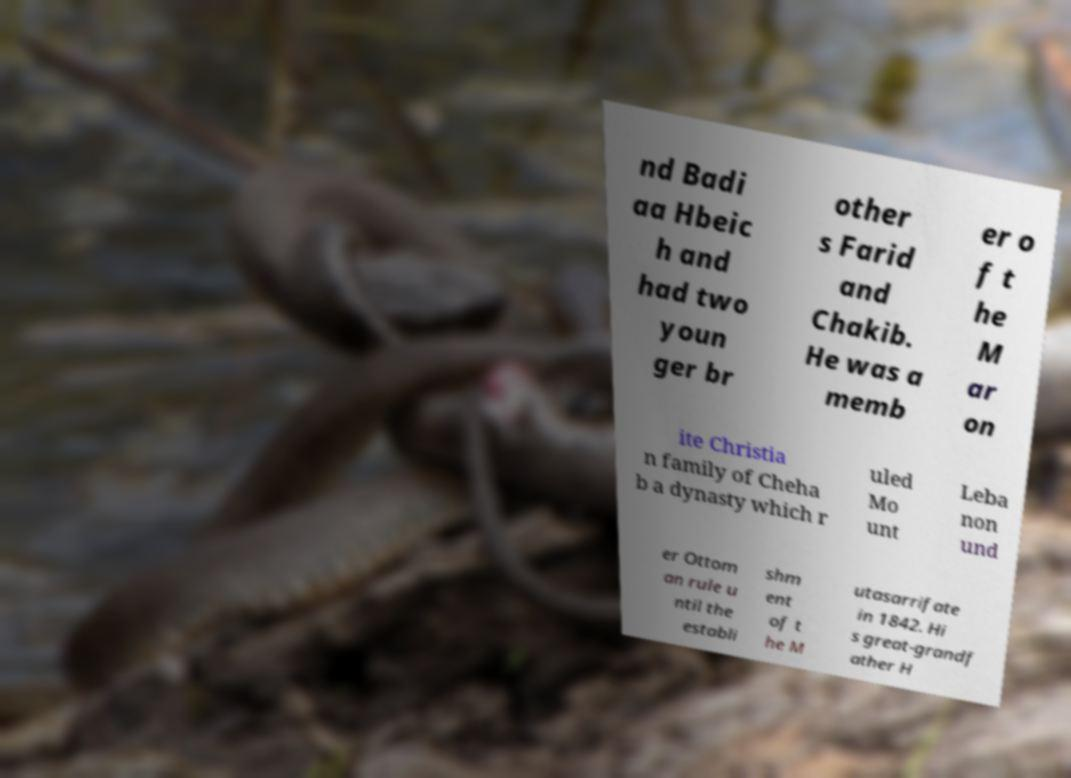Please read and relay the text visible in this image. What does it say? nd Badi aa Hbeic h and had two youn ger br other s Farid and Chakib. He was a memb er o f t he M ar on ite Christia n family of Cheha b a dynasty which r uled Mo unt Leba non und er Ottom an rule u ntil the establi shm ent of t he M utasarrifate in 1842. Hi s great-grandf ather H 